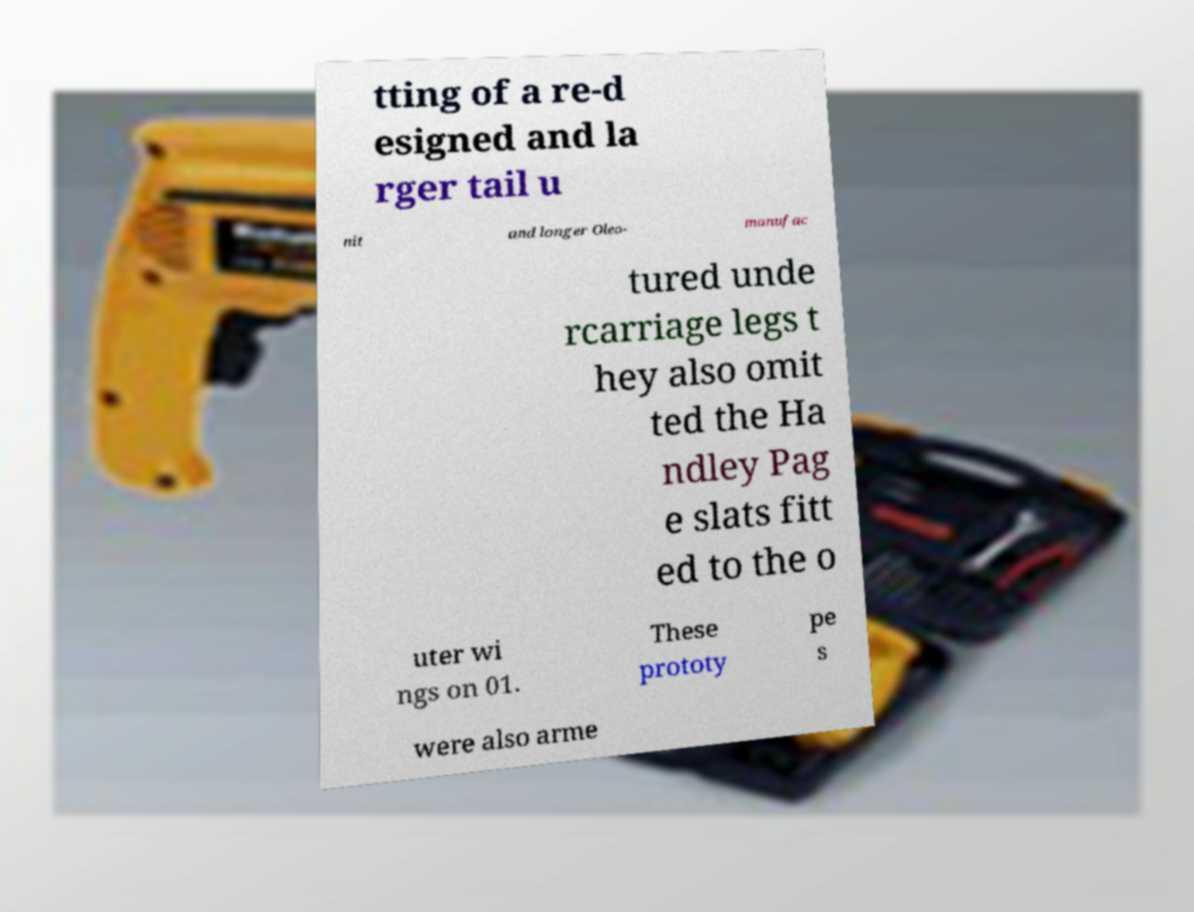There's text embedded in this image that I need extracted. Can you transcribe it verbatim? tting of a re-d esigned and la rger tail u nit and longer Oleo- manufac tured unde rcarriage legs t hey also omit ted the Ha ndley Pag e slats fitt ed to the o uter wi ngs on 01. These prototy pe s were also arme 